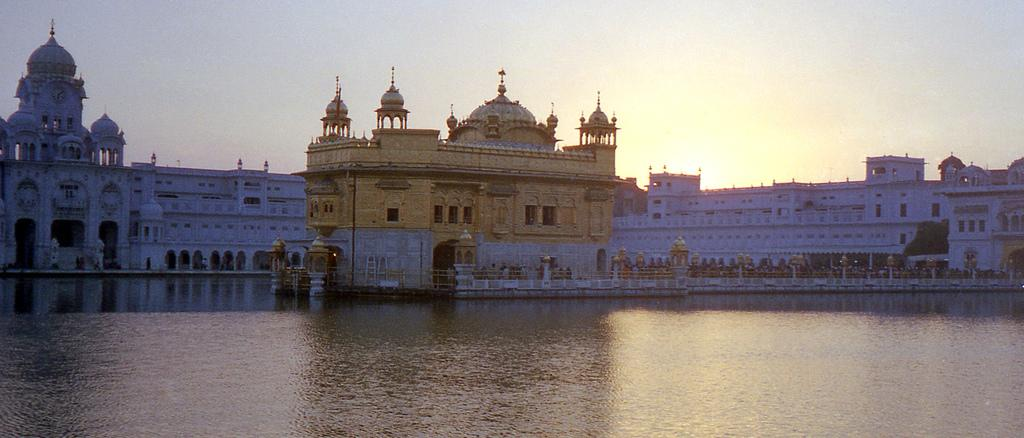What is located in the front of the image? There is: There is water in the front of the image. What famous landmark can be seen in the background? The Golden Temple is visible in the background. What type of buildings are present in the background? There are white-colored buildings in the background. What can be seen in the sky in the background? The sky is visible in the background, and the sun is observable in it. What is the texture of the giraffe's fur in the image? There is no giraffe present in the image, so we cannot determine the texture of its fur. 